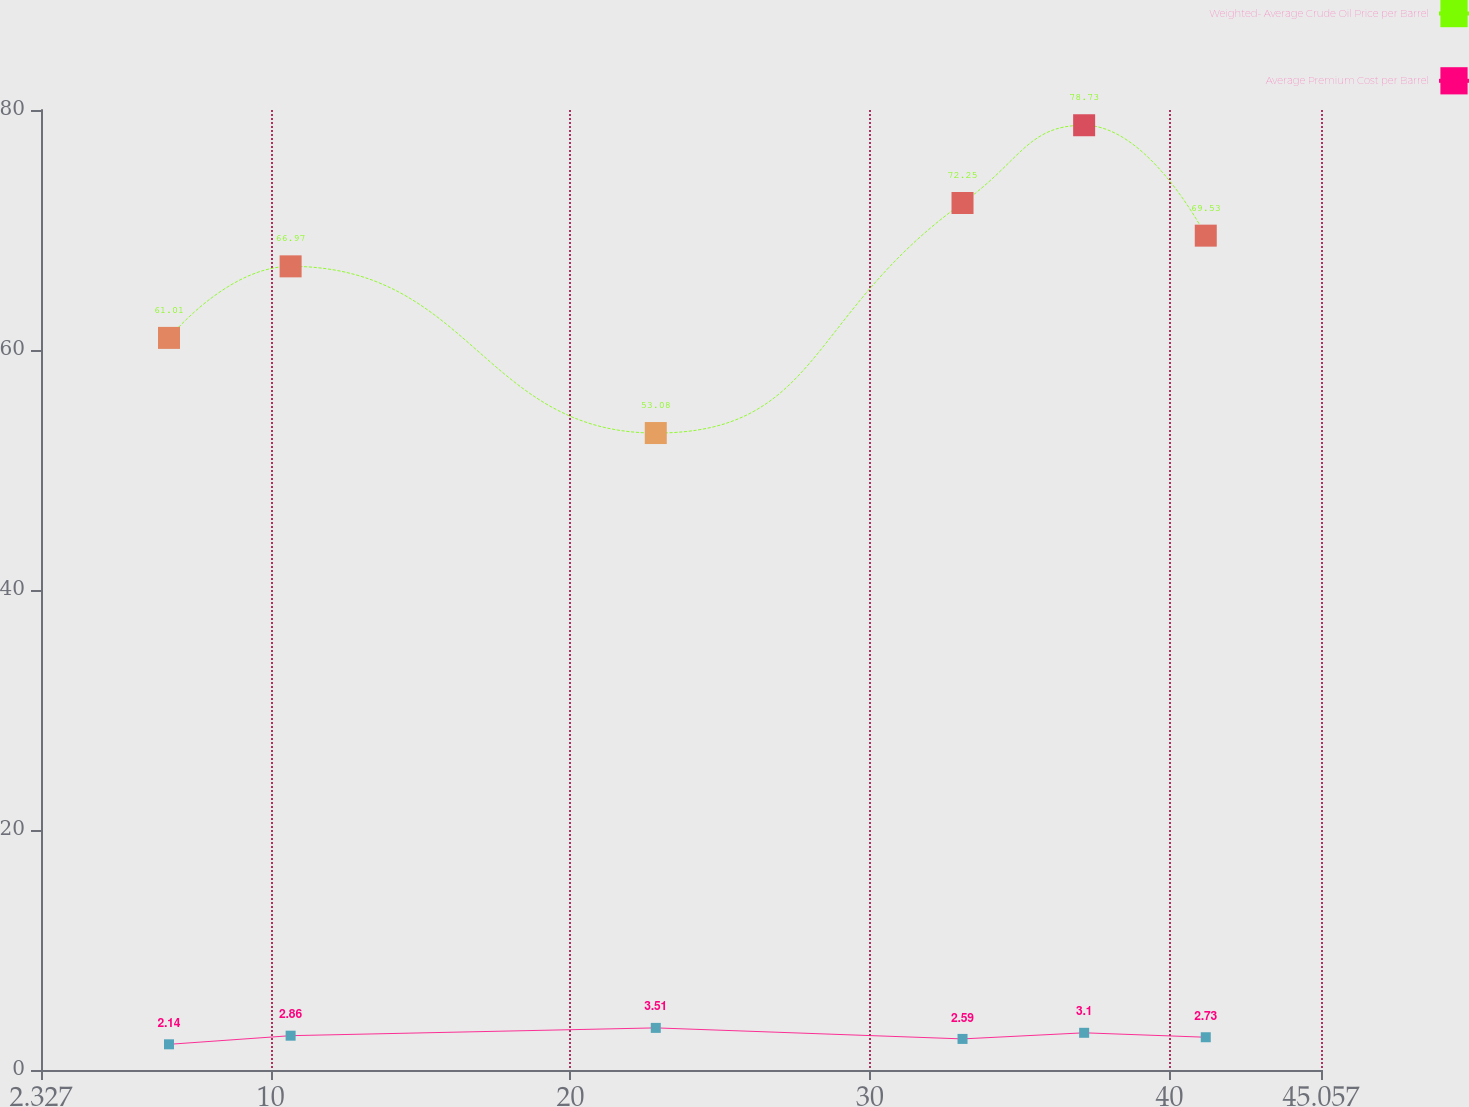Convert chart to OTSL. <chart><loc_0><loc_0><loc_500><loc_500><line_chart><ecel><fcel>Weighted- Average Crude Oil Price per Barrel<fcel>Average Premium Cost per Barrel<nl><fcel>6.6<fcel>61.01<fcel>2.14<nl><fcel>10.66<fcel>66.97<fcel>2.86<nl><fcel>22.85<fcel>53.08<fcel>3.51<nl><fcel>33.09<fcel>72.25<fcel>2.59<nl><fcel>37.15<fcel>78.73<fcel>3.1<nl><fcel>41.21<fcel>69.53<fcel>2.73<nl><fcel>45.27<fcel>64.41<fcel>3.38<nl><fcel>49.33<fcel>56.54<fcel>2.46<nl></chart> 